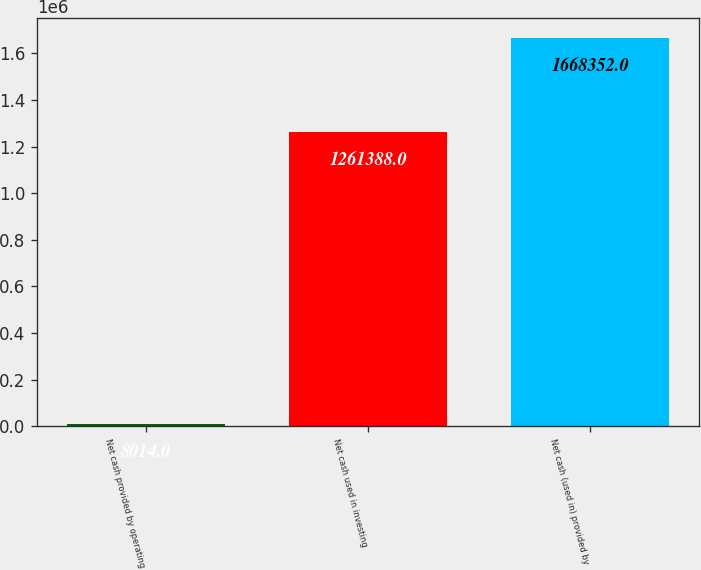<chart> <loc_0><loc_0><loc_500><loc_500><bar_chart><fcel>Net cash provided by operating<fcel>Net cash used in investing<fcel>Net cash (used in) provided by<nl><fcel>8014<fcel>1.26139e+06<fcel>1.66835e+06<nl></chart> 